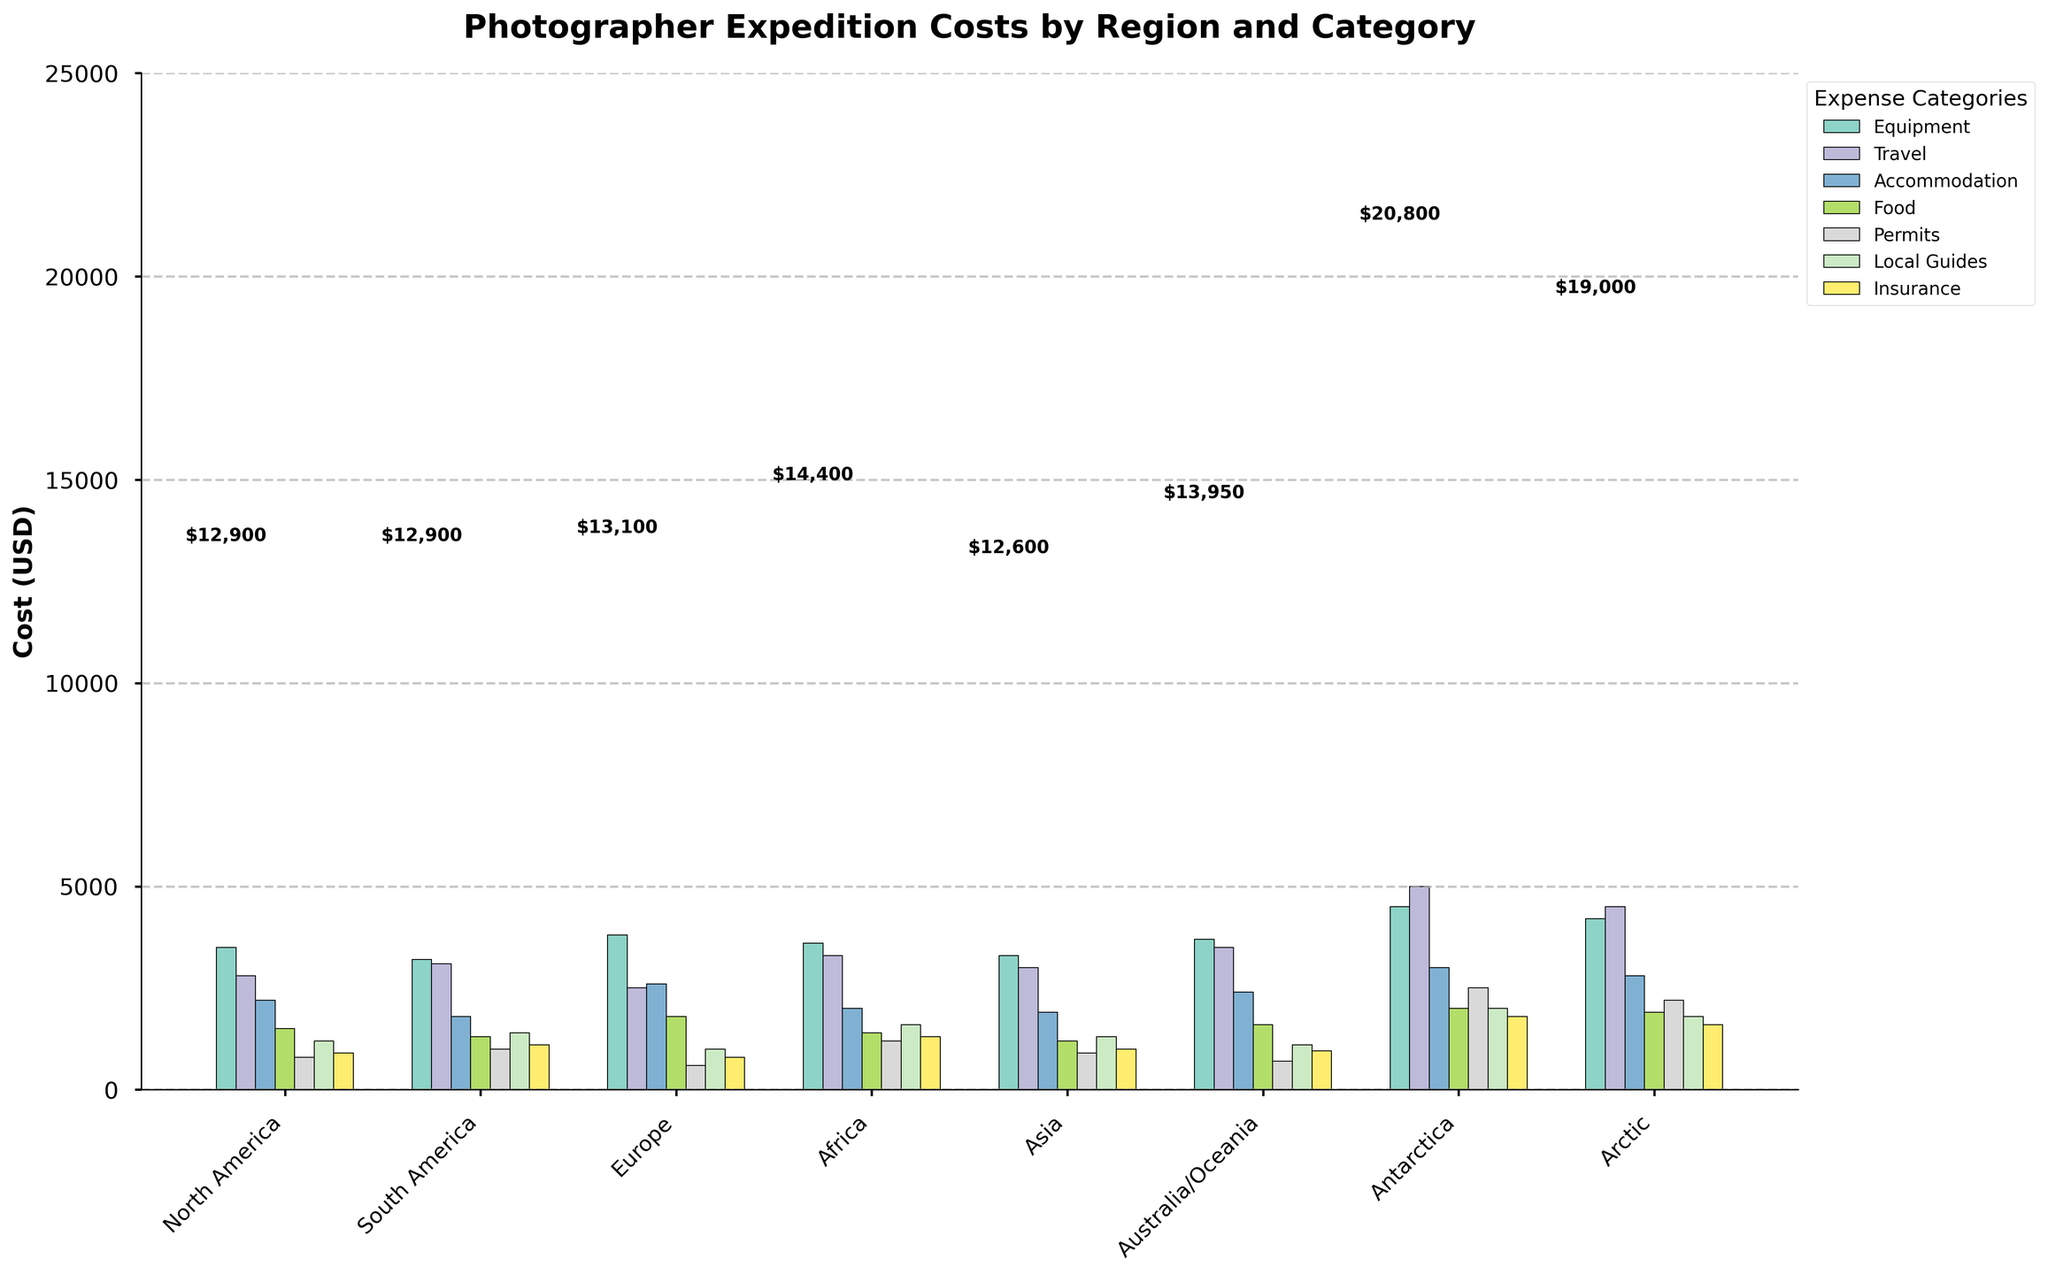What region has the highest equipment cost? The equipment costs are represented by the tallest bars among the categories, and the highest one is found by identifying the tallest bar in each region's group. Antarctica's equipment cost is highest at $4,500.
Answer: Antarctica Which region has the lowest accommodation cost? By examining the bars for accommodation costs across all regions, the shortest bar identifies the region with the lowest cost. Asia has the lowest accommodation cost at $1,900.
Answer: Asia What are the total costs for South America? Sum the costs of each category for South America: 3200 (Equipment) + 3100 (Travel) + 1800 (Accommodation) + 1300 (Food) + 1000 (Permits) + 1400 (Local Guides) + 1100 (Insurance) = 12,900.
Answer: $12,900 Compare the food costs between Africa and Asia. Which one is higher? Locate the food cost bars for both Africa and Asia and compare their heights. Africa's food cost is $1,400, while Asia's is $1,200. Africa's cost is higher.
Answer: Africa How much more is the insurance cost in the Arctic compared to Europe? Subtract Europe's insurance cost from the Arctic's: 1,600 (Arctic) - 800 (Europe) = 800.
Answer: $800 What are the average travel costs across all regions? Calculate the average of the travel costs: (2800 + 3100 + 2500 + 3300 + 3000 + 3500 + 5000 + 4500) / 8 = 3912.5.
Answer: $3,912.50 Which two regions have equal accommodation costs? By examining the accommodation cost bars for all regions, you can see that North America and Asia both have an accommodation cost of $2,200.
Answer: North America and Asia Is the local guide cost higher in North America or Australia/Oceania? Compare the local guide cost bars for both regions. North America's local guide cost is $1,200, while Australia/Oceania's is $1,100. North America's cost is higher.
Answer: North America What is the difference in permit costs between Antarctica and Arctic? Subtract the permit cost in the Arctic from that in Antarctica: 2,500 (Antarctica) - 2,200 (Arctic) = 300.
Answer: $300 